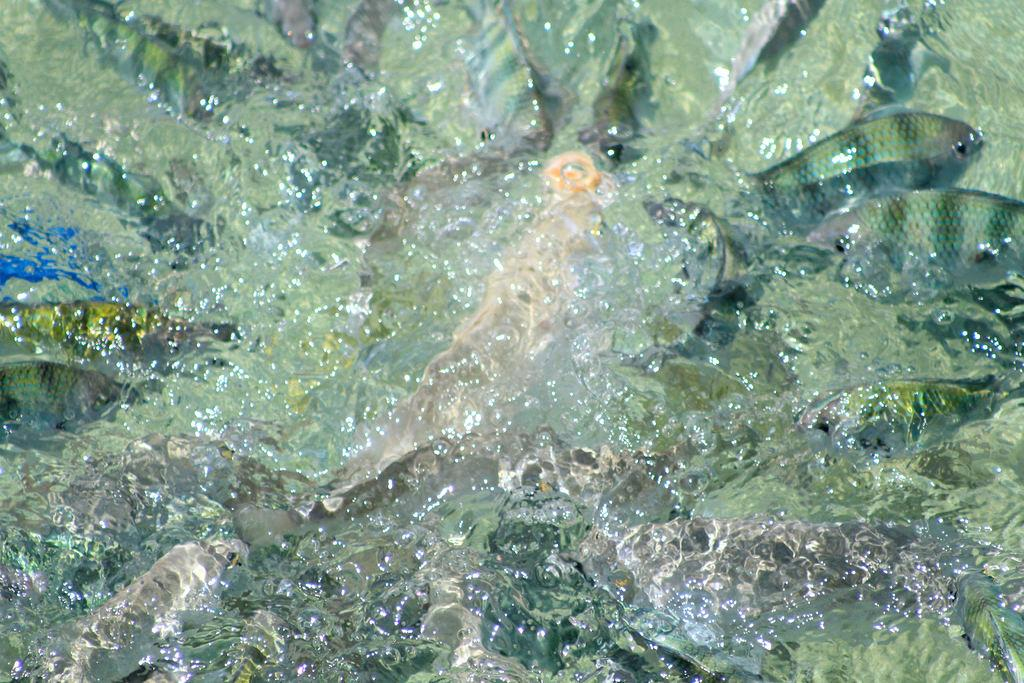What type of animals can be seen in the image? There are fishes in the image. Where are the fishes located? The fishes are in water. Can you tell me how many trips the grandmother took to the lake in the image? There is no mention of a grandmother or a lake in the image; it features fishes in water. 